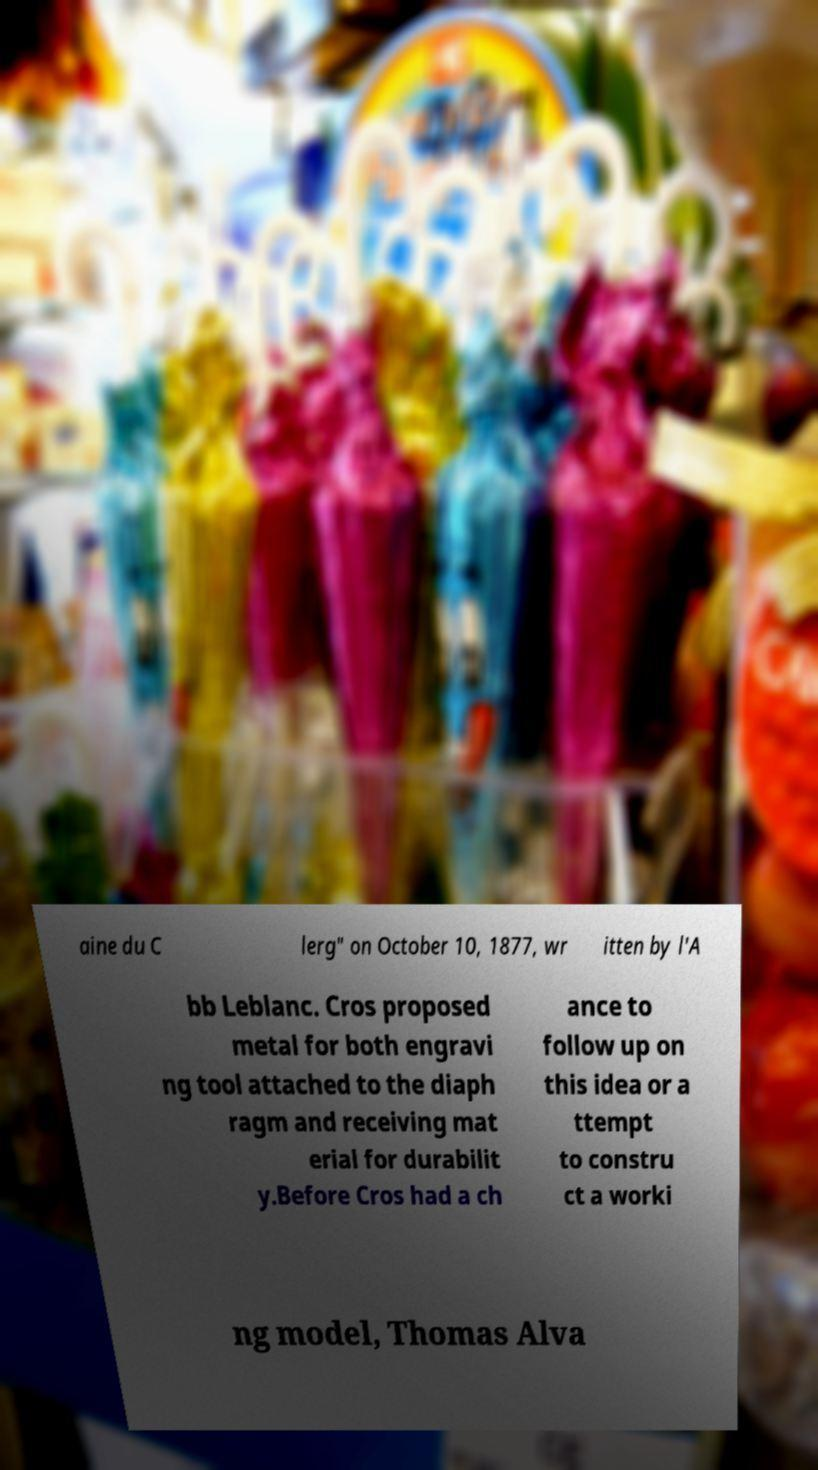Can you accurately transcribe the text from the provided image for me? aine du C lerg" on October 10, 1877, wr itten by l'A bb Leblanc. Cros proposed metal for both engravi ng tool attached to the diaph ragm and receiving mat erial for durabilit y.Before Cros had a ch ance to follow up on this idea or a ttempt to constru ct a worki ng model, Thomas Alva 